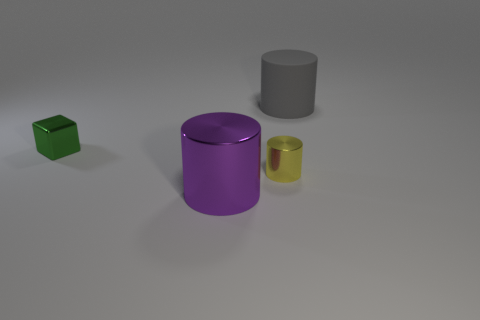Add 4 large blue matte objects. How many objects exist? 8 Subtract all cylinders. How many objects are left? 1 Add 4 metal objects. How many metal objects are left? 7 Add 4 big blue rubber spheres. How many big blue rubber spheres exist? 4 Subtract 0 brown spheres. How many objects are left? 4 Subtract all things. Subtract all green cylinders. How many objects are left? 0 